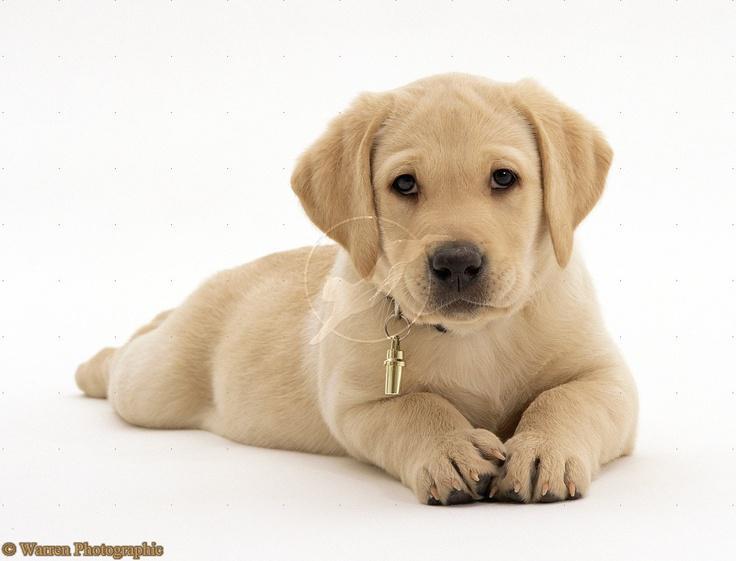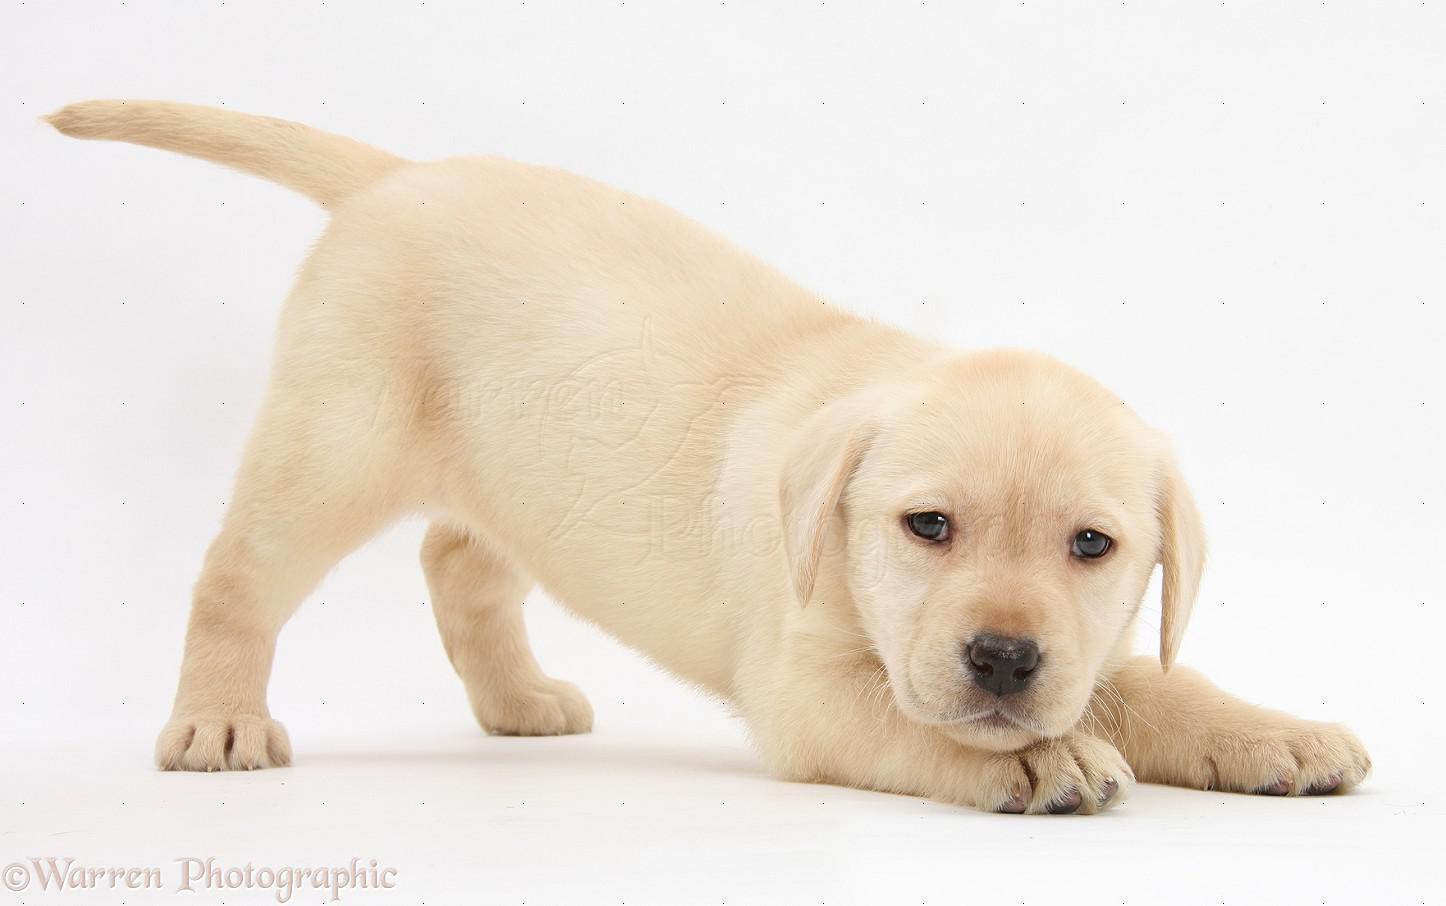The first image is the image on the left, the second image is the image on the right. Assess this claim about the two images: "An image shows at least one reclining dog wearing something around its neck.". Correct or not? Answer yes or no. Yes. The first image is the image on the left, the second image is the image on the right. Evaluate the accuracy of this statement regarding the images: "In one if the pictures a puppy is laying on a dark cushion.". Is it true? Answer yes or no. No. 